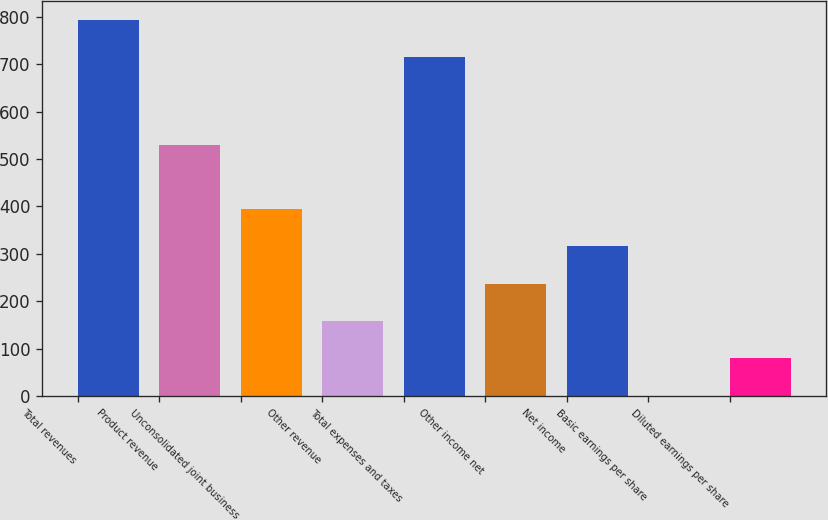Convert chart. <chart><loc_0><loc_0><loc_500><loc_500><bar_chart><fcel>Total revenues<fcel>Product revenue<fcel>Unconsolidated joint business<fcel>Other revenue<fcel>Total expenses and taxes<fcel>Other income net<fcel>Net income<fcel>Basic earnings per share<fcel>Diluted earnings per share<nl><fcel>793.58<fcel>529.6<fcel>394.81<fcel>158.17<fcel>714.7<fcel>237.05<fcel>315.93<fcel>0.41<fcel>79.29<nl></chart> 